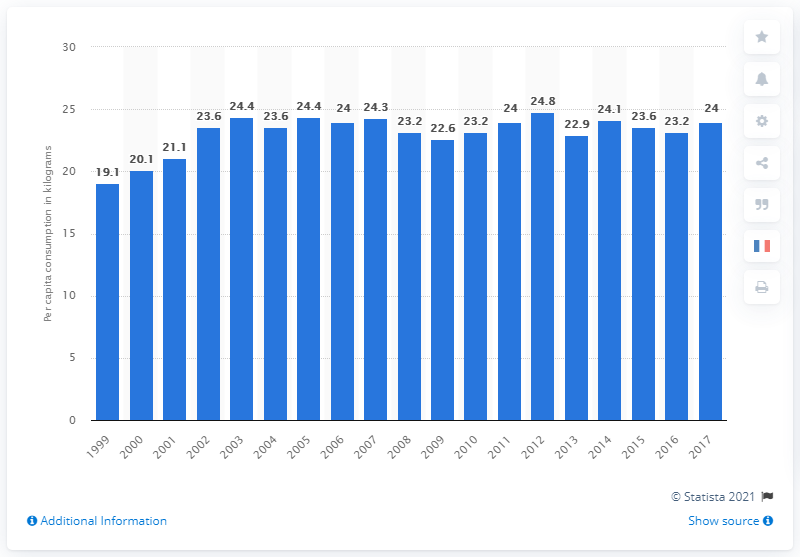Point out several critical features in this image. In 2012, the French consumed the highest amount of fish. 